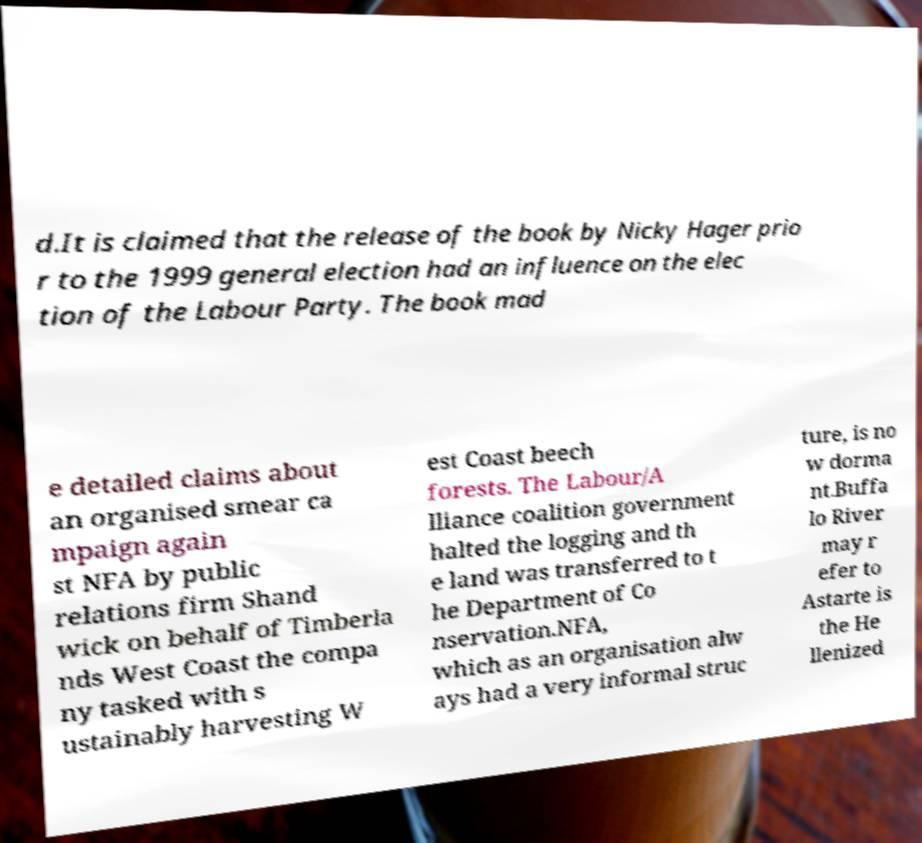Please read and relay the text visible in this image. What does it say? d.It is claimed that the release of the book by Nicky Hager prio r to the 1999 general election had an influence on the elec tion of the Labour Party. The book mad e detailed claims about an organised smear ca mpaign again st NFA by public relations firm Shand wick on behalf of Timberla nds West Coast the compa ny tasked with s ustainably harvesting W est Coast beech forests. The Labour/A lliance coalition government halted the logging and th e land was transferred to t he Department of Co nservation.NFA, which as an organisation alw ays had a very informal struc ture, is no w dorma nt.Buffa lo River may r efer to Astarte is the He llenized 